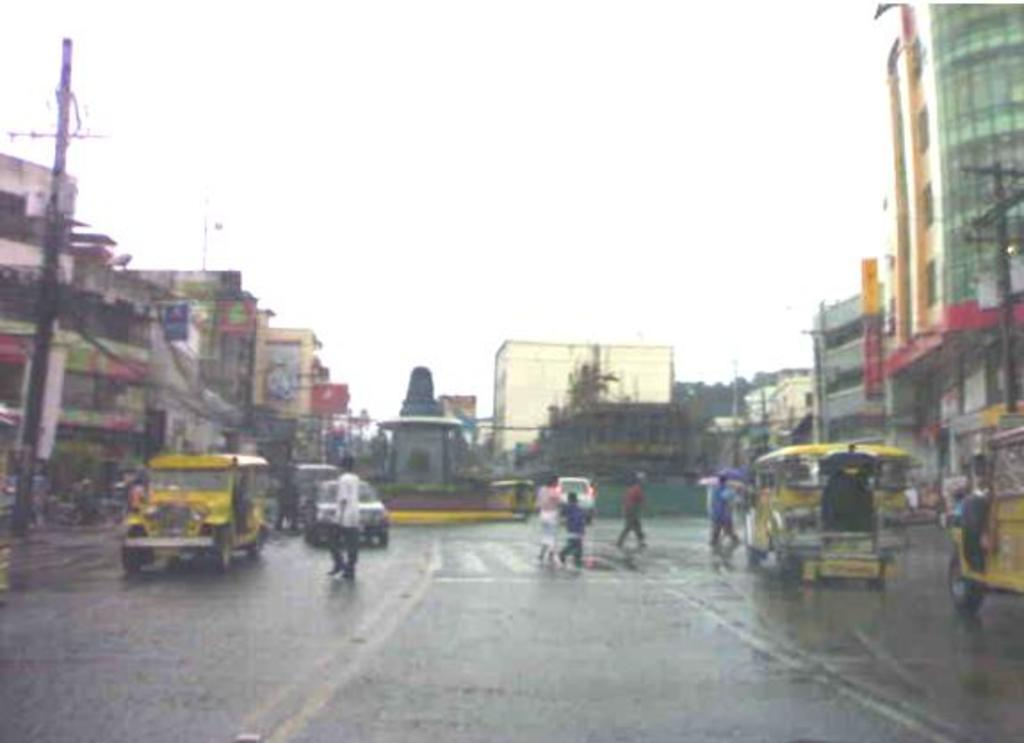Who or what can be seen in the image? There are people in the image. What else is present in the image besides people? There are vehicles, buildings, current poles, and trees in the image. What is visible at the top of the image? The sky is visible at the top of the image. What type of silver is being used to make the tooth on the throne in the image? There is no silver, tooth, or throne present in the image. 